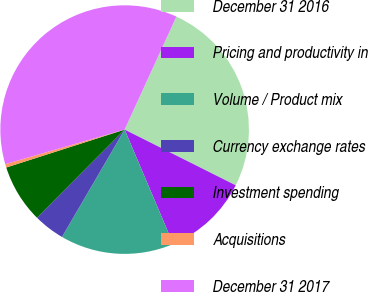Convert chart to OTSL. <chart><loc_0><loc_0><loc_500><loc_500><pie_chart><fcel>December 31 2016<fcel>Pricing and productivity in<fcel>Volume / Product mix<fcel>Currency exchange rates<fcel>Investment spending<fcel>Acquisitions<fcel>December 31 2017<nl><fcel>25.56%<fcel>11.21%<fcel>14.8%<fcel>4.04%<fcel>7.62%<fcel>0.45%<fcel>36.32%<nl></chart> 